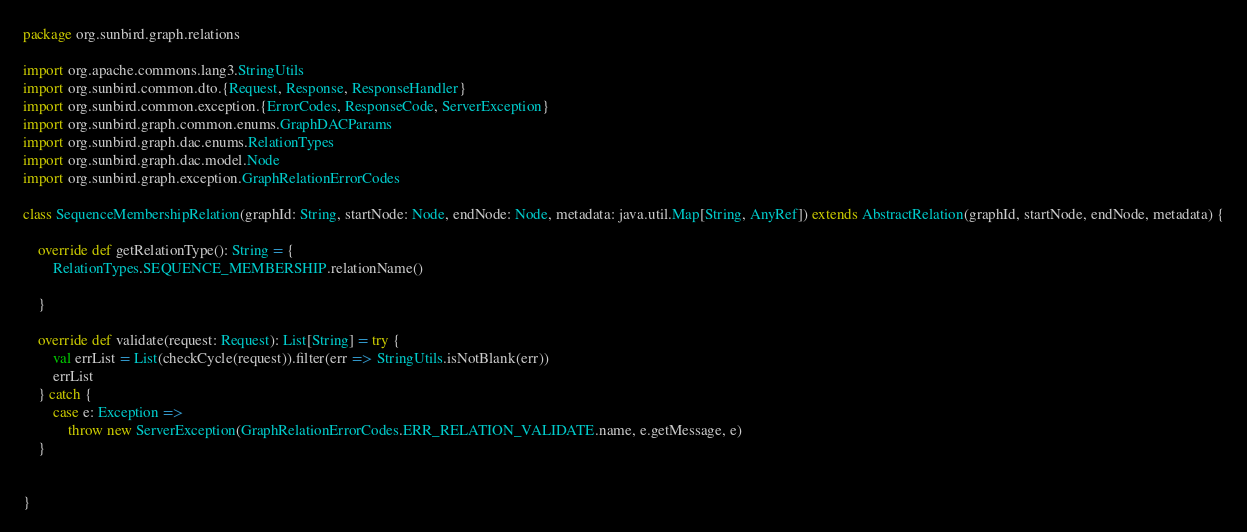Convert code to text. <code><loc_0><loc_0><loc_500><loc_500><_Scala_>package org.sunbird.graph.relations

import org.apache.commons.lang3.StringUtils
import org.sunbird.common.dto.{Request, Response, ResponseHandler}
import org.sunbird.common.exception.{ErrorCodes, ResponseCode, ServerException}
import org.sunbird.graph.common.enums.GraphDACParams
import org.sunbird.graph.dac.enums.RelationTypes
import org.sunbird.graph.dac.model.Node
import org.sunbird.graph.exception.GraphRelationErrorCodes

class SequenceMembershipRelation(graphId: String, startNode: Node, endNode: Node, metadata: java.util.Map[String, AnyRef]) extends AbstractRelation(graphId, startNode, endNode, metadata) {

    override def getRelationType(): String = {
        RelationTypes.SEQUENCE_MEMBERSHIP.relationName()

    }

    override def validate(request: Request): List[String] = try {
        val errList = List(checkCycle(request)).filter(err => StringUtils.isNotBlank(err))
        errList
    } catch {
        case e: Exception =>
            throw new ServerException(GraphRelationErrorCodes.ERR_RELATION_VALIDATE.name, e.getMessage, e)
    }


}
</code> 